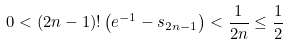Convert formula to latex. <formula><loc_0><loc_0><loc_500><loc_500>0 < ( 2 n - 1 ) ! \left ( e ^ { - 1 } - s _ { 2 n - 1 } \right ) < { \frac { 1 } { 2 n } } \leq { \frac { 1 } { 2 } }</formula> 